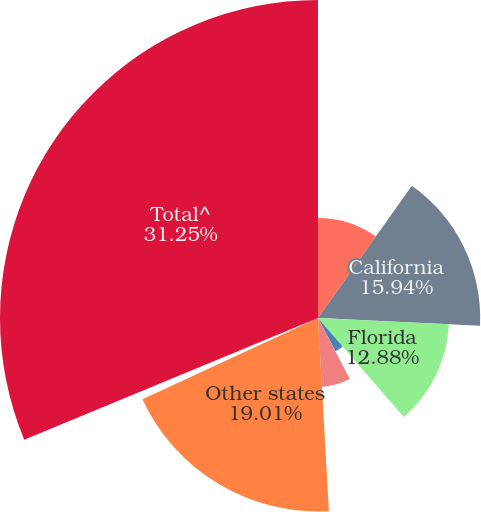Convert chart. <chart><loc_0><loc_0><loc_500><loc_500><pie_chart><fcel>New York<fcel>California<fcel>Florida<fcel>Texas<fcel>Pennsylvania<fcel>Other states<fcel>Foreign<fcel>Total^<nl><fcel>9.82%<fcel>15.94%<fcel>12.88%<fcel>3.7%<fcel>6.76%<fcel>19.01%<fcel>0.64%<fcel>31.25%<nl></chart> 